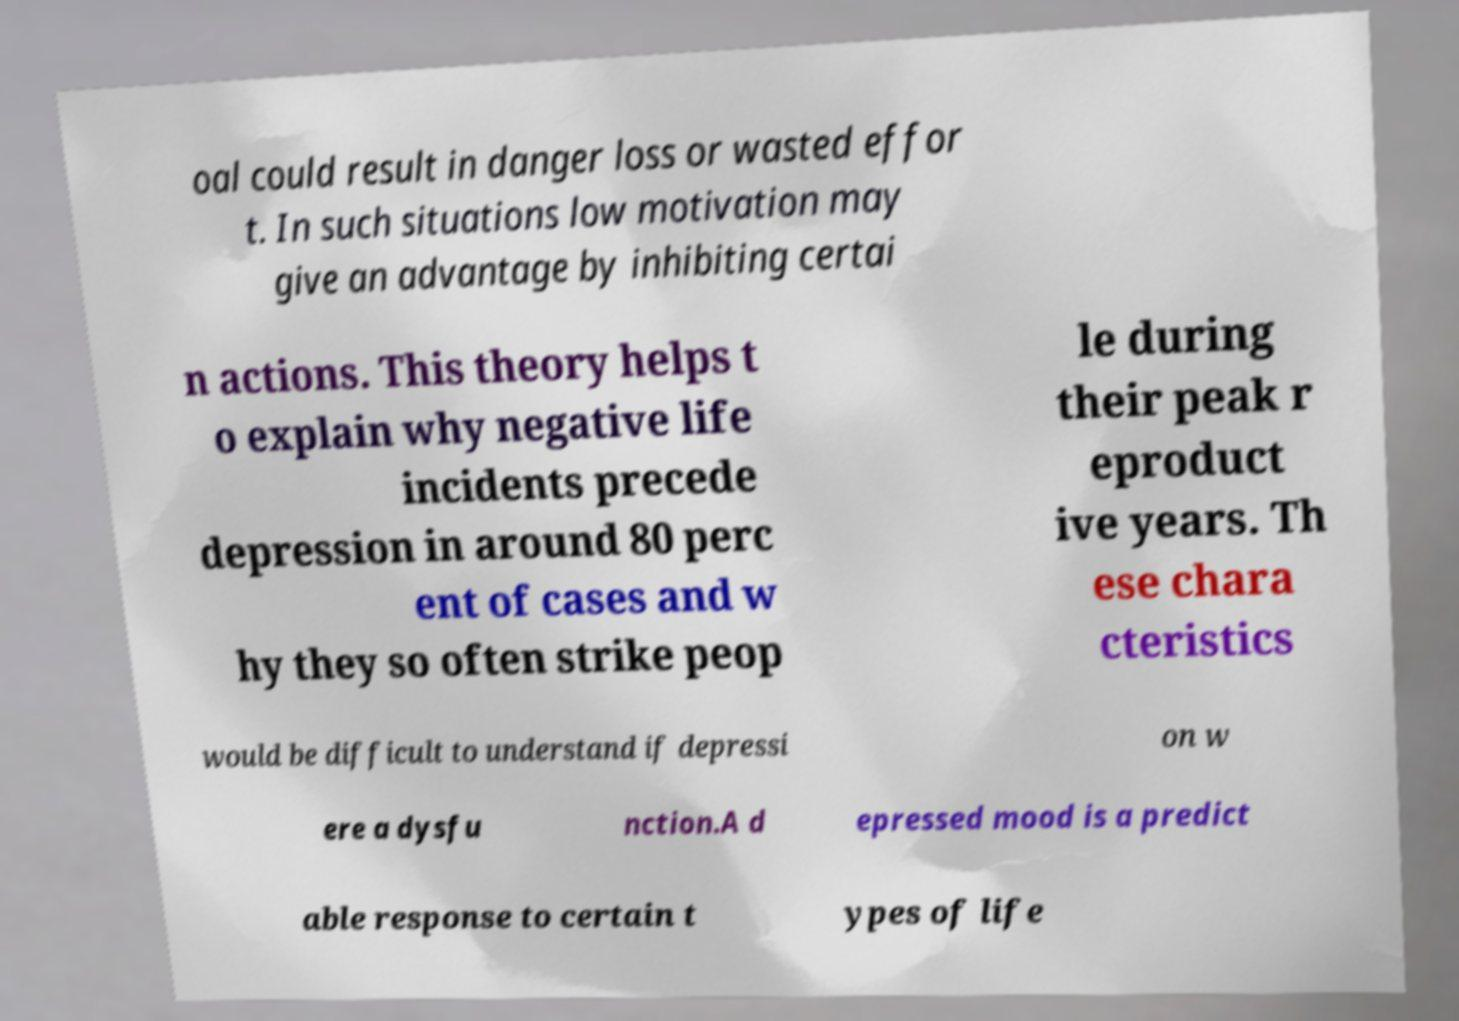There's text embedded in this image that I need extracted. Can you transcribe it verbatim? oal could result in danger loss or wasted effor t. In such situations low motivation may give an advantage by inhibiting certai n actions. This theory helps t o explain why negative life incidents precede depression in around 80 perc ent of cases and w hy they so often strike peop le during their peak r eproduct ive years. Th ese chara cteristics would be difficult to understand if depressi on w ere a dysfu nction.A d epressed mood is a predict able response to certain t ypes of life 